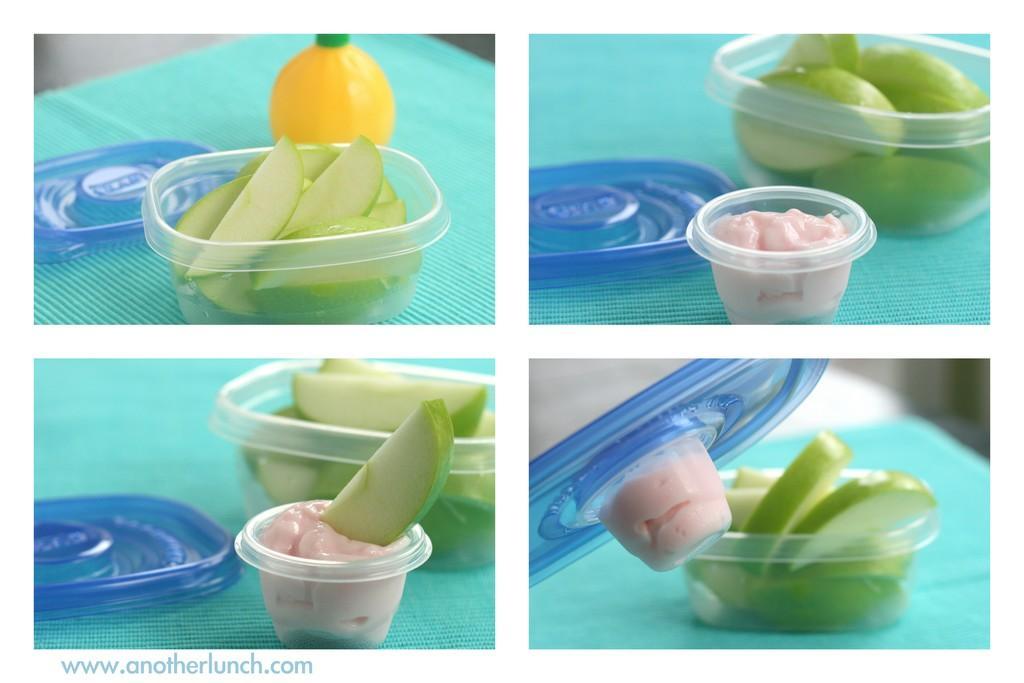How would you summarize this image in a sentence or two? This is a collage image of fruits and spices which was placed in a plastic tubs. 